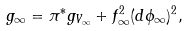Convert formula to latex. <formula><loc_0><loc_0><loc_500><loc_500>g _ { \infty } = \pi ^ { * } g _ { V _ { \infty } } + f _ { \infty } ^ { 2 } ( d \phi _ { \infty } ) ^ { 2 } ,</formula> 